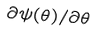<formula> <loc_0><loc_0><loc_500><loc_500>\partial \psi ( \theta ) / \partial \theta</formula> 